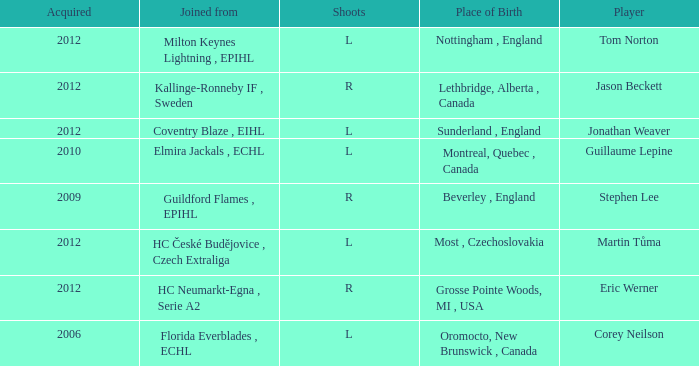Who acquired tom norton? 2012.0. 